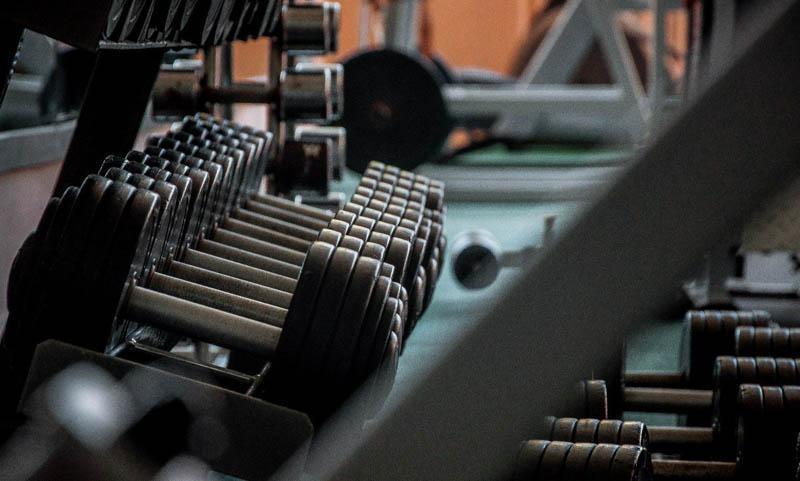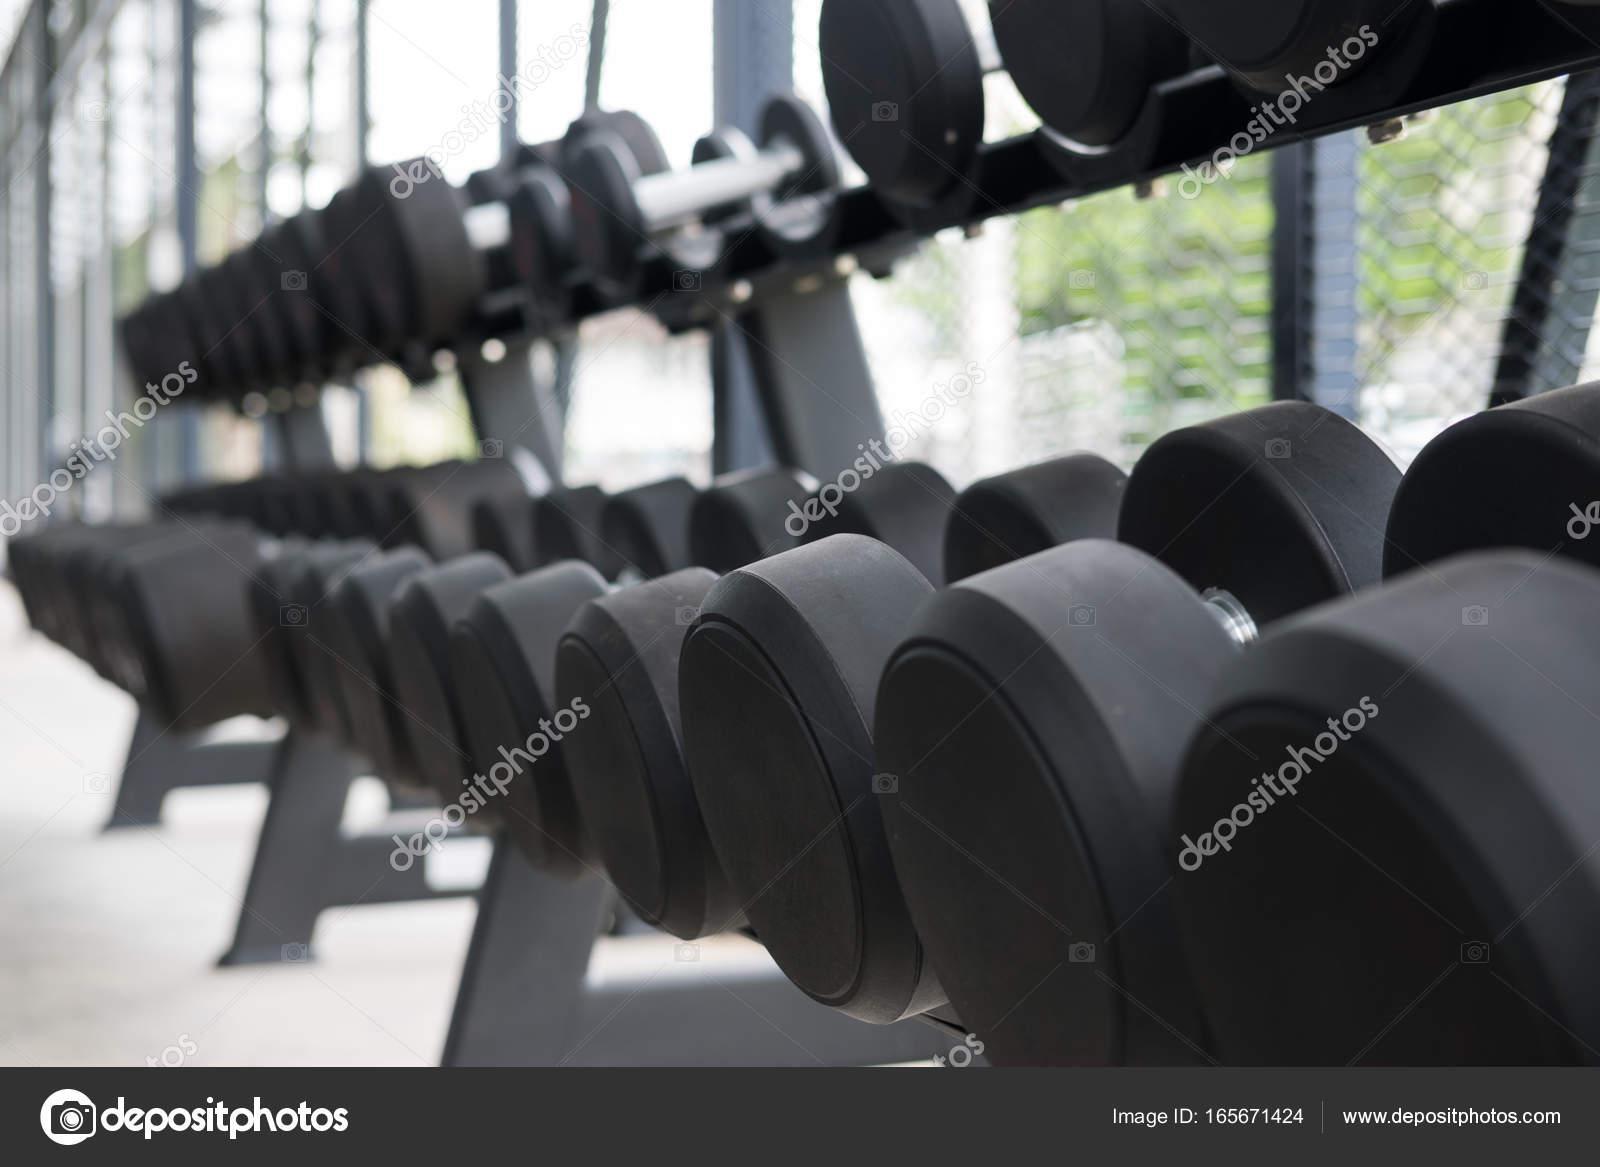The first image is the image on the left, the second image is the image on the right. Evaluate the accuracy of this statement regarding the images: "In at least one image there is a total of two racks of black weights.". Is it true? Answer yes or no. Yes. 